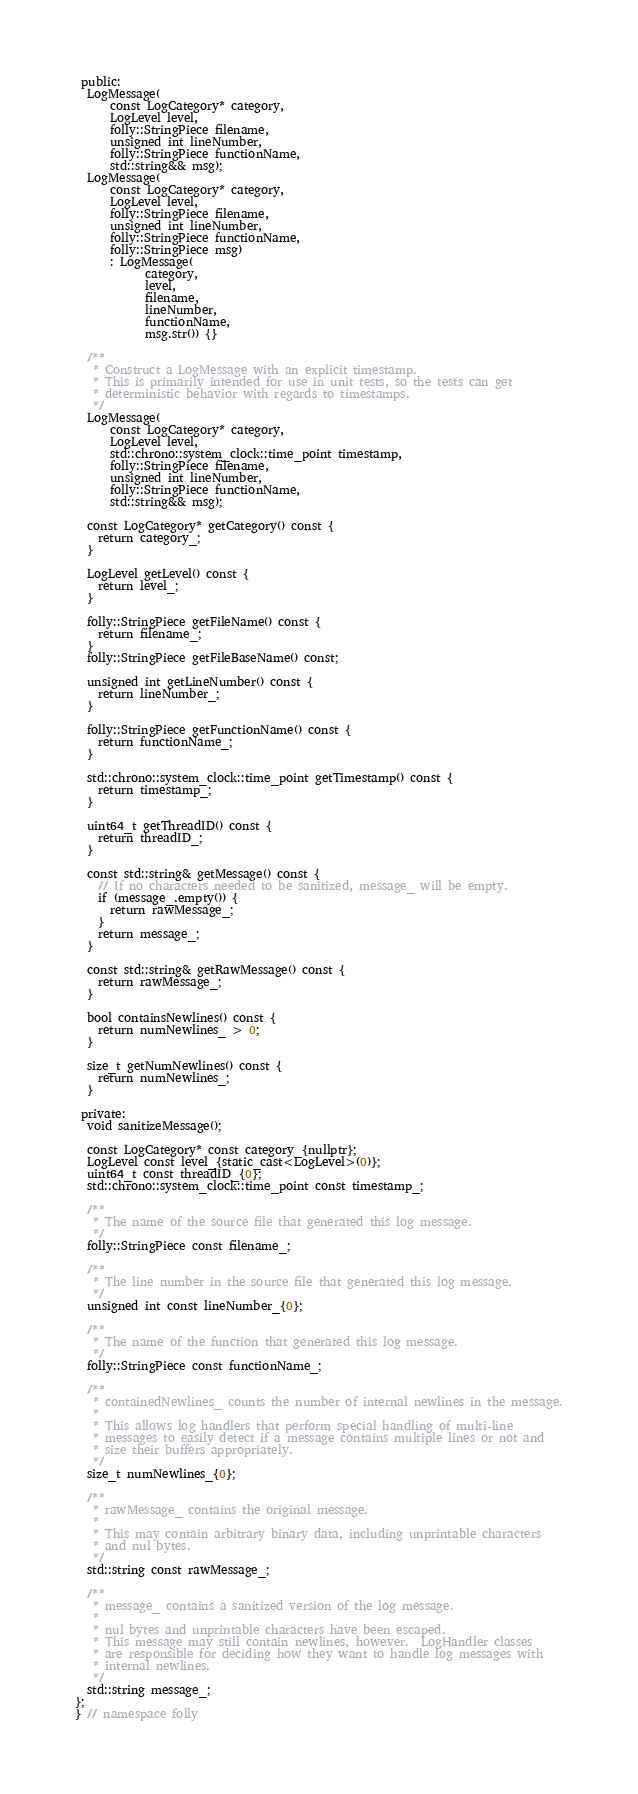<code> <loc_0><loc_0><loc_500><loc_500><_C_> public:
  LogMessage(
      const LogCategory* category,
      LogLevel level,
      folly::StringPiece filename,
      unsigned int lineNumber,
      folly::StringPiece functionName,
      std::string&& msg);
  LogMessage(
      const LogCategory* category,
      LogLevel level,
      folly::StringPiece filename,
      unsigned int lineNumber,
      folly::StringPiece functionName,
      folly::StringPiece msg)
      : LogMessage(
            category,
            level,
            filename,
            lineNumber,
            functionName,
            msg.str()) {}

  /**
   * Construct a LogMessage with an explicit timestamp.
   * This is primarily intended for use in unit tests, so the tests can get
   * deterministic behavior with regards to timestamps.
   */
  LogMessage(
      const LogCategory* category,
      LogLevel level,
      std::chrono::system_clock::time_point timestamp,
      folly::StringPiece filename,
      unsigned int lineNumber,
      folly::StringPiece functionName,
      std::string&& msg);

  const LogCategory* getCategory() const {
    return category_;
  }

  LogLevel getLevel() const {
    return level_;
  }

  folly::StringPiece getFileName() const {
    return filename_;
  }
  folly::StringPiece getFileBaseName() const;

  unsigned int getLineNumber() const {
    return lineNumber_;
  }

  folly::StringPiece getFunctionName() const {
    return functionName_;
  }

  std::chrono::system_clock::time_point getTimestamp() const {
    return timestamp_;
  }

  uint64_t getThreadID() const {
    return threadID_;
  }

  const std::string& getMessage() const {
    // If no characters needed to be sanitized, message_ will be empty.
    if (message_.empty()) {
      return rawMessage_;
    }
    return message_;
  }

  const std::string& getRawMessage() const {
    return rawMessage_;
  }

  bool containsNewlines() const {
    return numNewlines_ > 0;
  }

  size_t getNumNewlines() const {
    return numNewlines_;
  }

 private:
  void sanitizeMessage();

  const LogCategory* const category_{nullptr};
  LogLevel const level_{static_cast<LogLevel>(0)};
  uint64_t const threadID_{0};
  std::chrono::system_clock::time_point const timestamp_;

  /**
   * The name of the source file that generated this log message.
   */
  folly::StringPiece const filename_;

  /**
   * The line number in the source file that generated this log message.
   */
  unsigned int const lineNumber_{0};

  /**
   * The name of the function that generated this log message.
   */
  folly::StringPiece const functionName_;

  /**
   * containedNewlines_ counts the number of internal newlines in the message.
   *
   * This allows log handlers that perform special handling of multi-line
   * messages to easily detect if a message contains multiple lines or not and
   * size their buffers appropriately.
   */
  size_t numNewlines_{0};

  /**
   * rawMessage_ contains the original message.
   *
   * This may contain arbitrary binary data, including unprintable characters
   * and nul bytes.
   */
  std::string const rawMessage_;

  /**
   * message_ contains a sanitized version of the log message.
   *
   * nul bytes and unprintable characters have been escaped.
   * This message may still contain newlines, however.  LogHandler classes
   * are responsible for deciding how they want to handle log messages with
   * internal newlines.
   */
  std::string message_;
};
} // namespace folly
</code> 